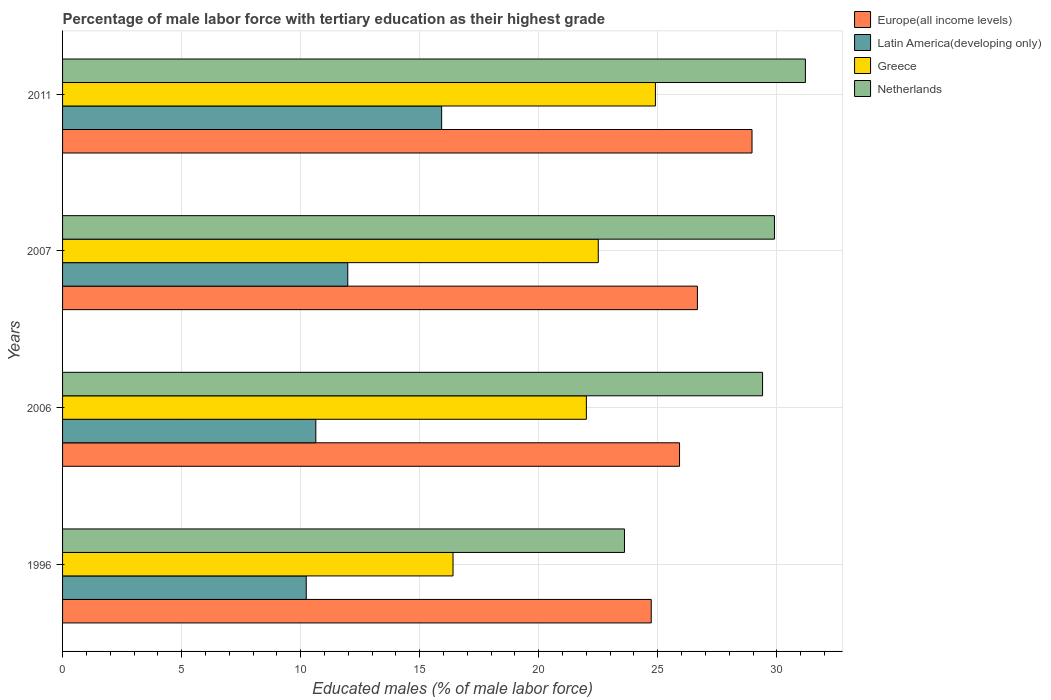How many different coloured bars are there?
Your response must be concise. 4. Are the number of bars per tick equal to the number of legend labels?
Your response must be concise. Yes. In how many cases, is the number of bars for a given year not equal to the number of legend labels?
Offer a very short reply. 0. What is the percentage of male labor force with tertiary education in Greece in 2011?
Provide a succinct answer. 24.9. Across all years, what is the maximum percentage of male labor force with tertiary education in Latin America(developing only)?
Provide a succinct answer. 15.92. Across all years, what is the minimum percentage of male labor force with tertiary education in Latin America(developing only)?
Your answer should be compact. 10.23. In which year was the percentage of male labor force with tertiary education in Greece minimum?
Offer a terse response. 1996. What is the total percentage of male labor force with tertiary education in Netherlands in the graph?
Offer a terse response. 114.1. What is the difference between the percentage of male labor force with tertiary education in Netherlands in 2006 and that in 2011?
Keep it short and to the point. -1.8. What is the difference between the percentage of male labor force with tertiary education in Latin America(developing only) in 2011 and the percentage of male labor force with tertiary education in Europe(all income levels) in 2007?
Your answer should be very brief. -10.74. What is the average percentage of male labor force with tertiary education in Latin America(developing only) per year?
Make the answer very short. 12.19. In the year 2006, what is the difference between the percentage of male labor force with tertiary education in Netherlands and percentage of male labor force with tertiary education in Latin America(developing only)?
Your response must be concise. 18.76. In how many years, is the percentage of male labor force with tertiary education in Europe(all income levels) greater than 3 %?
Provide a succinct answer. 4. What is the ratio of the percentage of male labor force with tertiary education in Netherlands in 2006 to that in 2011?
Keep it short and to the point. 0.94. What is the difference between the highest and the second highest percentage of male labor force with tertiary education in Latin America(developing only)?
Keep it short and to the point. 3.94. What is the difference between the highest and the lowest percentage of male labor force with tertiary education in Netherlands?
Keep it short and to the point. 7.6. What does the 1st bar from the bottom in 2011 represents?
Provide a short and direct response. Europe(all income levels). Are the values on the major ticks of X-axis written in scientific E-notation?
Provide a succinct answer. No. Does the graph contain any zero values?
Make the answer very short. No. Does the graph contain grids?
Provide a succinct answer. Yes. Where does the legend appear in the graph?
Keep it short and to the point. Top right. How many legend labels are there?
Give a very brief answer. 4. What is the title of the graph?
Your answer should be very brief. Percentage of male labor force with tertiary education as their highest grade. Does "Cyprus" appear as one of the legend labels in the graph?
Provide a succinct answer. No. What is the label or title of the X-axis?
Give a very brief answer. Educated males (% of male labor force). What is the Educated males (% of male labor force) of Europe(all income levels) in 1996?
Make the answer very short. 24.72. What is the Educated males (% of male labor force) of Latin America(developing only) in 1996?
Provide a succinct answer. 10.23. What is the Educated males (% of male labor force) in Greece in 1996?
Provide a succinct answer. 16.4. What is the Educated males (% of male labor force) in Netherlands in 1996?
Keep it short and to the point. 23.6. What is the Educated males (% of male labor force) of Europe(all income levels) in 2006?
Your answer should be very brief. 25.91. What is the Educated males (% of male labor force) in Latin America(developing only) in 2006?
Keep it short and to the point. 10.64. What is the Educated males (% of male labor force) in Netherlands in 2006?
Your answer should be very brief. 29.4. What is the Educated males (% of male labor force) of Europe(all income levels) in 2007?
Your answer should be very brief. 26.66. What is the Educated males (% of male labor force) of Latin America(developing only) in 2007?
Your response must be concise. 11.98. What is the Educated males (% of male labor force) in Greece in 2007?
Make the answer very short. 22.5. What is the Educated males (% of male labor force) of Netherlands in 2007?
Your answer should be very brief. 29.9. What is the Educated males (% of male labor force) of Europe(all income levels) in 2011?
Offer a terse response. 28.96. What is the Educated males (% of male labor force) in Latin America(developing only) in 2011?
Keep it short and to the point. 15.92. What is the Educated males (% of male labor force) in Greece in 2011?
Offer a terse response. 24.9. What is the Educated males (% of male labor force) of Netherlands in 2011?
Your response must be concise. 31.2. Across all years, what is the maximum Educated males (% of male labor force) of Europe(all income levels)?
Offer a terse response. 28.96. Across all years, what is the maximum Educated males (% of male labor force) in Latin America(developing only)?
Make the answer very short. 15.92. Across all years, what is the maximum Educated males (% of male labor force) in Greece?
Your response must be concise. 24.9. Across all years, what is the maximum Educated males (% of male labor force) in Netherlands?
Make the answer very short. 31.2. Across all years, what is the minimum Educated males (% of male labor force) in Europe(all income levels)?
Make the answer very short. 24.72. Across all years, what is the minimum Educated males (% of male labor force) in Latin America(developing only)?
Provide a succinct answer. 10.23. Across all years, what is the minimum Educated males (% of male labor force) in Greece?
Make the answer very short. 16.4. Across all years, what is the minimum Educated males (% of male labor force) in Netherlands?
Provide a short and direct response. 23.6. What is the total Educated males (% of male labor force) of Europe(all income levels) in the graph?
Give a very brief answer. 106.26. What is the total Educated males (% of male labor force) of Latin America(developing only) in the graph?
Make the answer very short. 48.77. What is the total Educated males (% of male labor force) of Greece in the graph?
Your answer should be compact. 85.8. What is the total Educated males (% of male labor force) in Netherlands in the graph?
Offer a terse response. 114.1. What is the difference between the Educated males (% of male labor force) in Europe(all income levels) in 1996 and that in 2006?
Provide a succinct answer. -1.19. What is the difference between the Educated males (% of male labor force) in Latin America(developing only) in 1996 and that in 2006?
Ensure brevity in your answer.  -0.4. What is the difference between the Educated males (% of male labor force) of Netherlands in 1996 and that in 2006?
Offer a terse response. -5.8. What is the difference between the Educated males (% of male labor force) in Europe(all income levels) in 1996 and that in 2007?
Provide a short and direct response. -1.94. What is the difference between the Educated males (% of male labor force) in Latin America(developing only) in 1996 and that in 2007?
Keep it short and to the point. -1.74. What is the difference between the Educated males (% of male labor force) in Europe(all income levels) in 1996 and that in 2011?
Give a very brief answer. -4.23. What is the difference between the Educated males (% of male labor force) of Latin America(developing only) in 1996 and that in 2011?
Keep it short and to the point. -5.69. What is the difference between the Educated males (% of male labor force) in Greece in 1996 and that in 2011?
Provide a short and direct response. -8.5. What is the difference between the Educated males (% of male labor force) in Netherlands in 1996 and that in 2011?
Your answer should be very brief. -7.6. What is the difference between the Educated males (% of male labor force) of Europe(all income levels) in 2006 and that in 2007?
Offer a very short reply. -0.75. What is the difference between the Educated males (% of male labor force) in Latin America(developing only) in 2006 and that in 2007?
Your response must be concise. -1.34. What is the difference between the Educated males (% of male labor force) in Netherlands in 2006 and that in 2007?
Keep it short and to the point. -0.5. What is the difference between the Educated males (% of male labor force) in Europe(all income levels) in 2006 and that in 2011?
Your answer should be very brief. -3.04. What is the difference between the Educated males (% of male labor force) in Latin America(developing only) in 2006 and that in 2011?
Give a very brief answer. -5.28. What is the difference between the Educated males (% of male labor force) in Netherlands in 2006 and that in 2011?
Your answer should be compact. -1.8. What is the difference between the Educated males (% of male labor force) of Europe(all income levels) in 2007 and that in 2011?
Provide a succinct answer. -2.29. What is the difference between the Educated males (% of male labor force) of Latin America(developing only) in 2007 and that in 2011?
Ensure brevity in your answer.  -3.94. What is the difference between the Educated males (% of male labor force) in Greece in 2007 and that in 2011?
Your answer should be compact. -2.4. What is the difference between the Educated males (% of male labor force) of Netherlands in 2007 and that in 2011?
Keep it short and to the point. -1.3. What is the difference between the Educated males (% of male labor force) in Europe(all income levels) in 1996 and the Educated males (% of male labor force) in Latin America(developing only) in 2006?
Your answer should be compact. 14.09. What is the difference between the Educated males (% of male labor force) in Europe(all income levels) in 1996 and the Educated males (% of male labor force) in Greece in 2006?
Your answer should be very brief. 2.72. What is the difference between the Educated males (% of male labor force) in Europe(all income levels) in 1996 and the Educated males (% of male labor force) in Netherlands in 2006?
Your answer should be very brief. -4.68. What is the difference between the Educated males (% of male labor force) in Latin America(developing only) in 1996 and the Educated males (% of male labor force) in Greece in 2006?
Offer a very short reply. -11.77. What is the difference between the Educated males (% of male labor force) in Latin America(developing only) in 1996 and the Educated males (% of male labor force) in Netherlands in 2006?
Offer a very short reply. -19.17. What is the difference between the Educated males (% of male labor force) of Greece in 1996 and the Educated males (% of male labor force) of Netherlands in 2006?
Provide a succinct answer. -13. What is the difference between the Educated males (% of male labor force) in Europe(all income levels) in 1996 and the Educated males (% of male labor force) in Latin America(developing only) in 2007?
Keep it short and to the point. 12.74. What is the difference between the Educated males (% of male labor force) in Europe(all income levels) in 1996 and the Educated males (% of male labor force) in Greece in 2007?
Offer a terse response. 2.22. What is the difference between the Educated males (% of male labor force) of Europe(all income levels) in 1996 and the Educated males (% of male labor force) of Netherlands in 2007?
Provide a succinct answer. -5.18. What is the difference between the Educated males (% of male labor force) of Latin America(developing only) in 1996 and the Educated males (% of male labor force) of Greece in 2007?
Make the answer very short. -12.27. What is the difference between the Educated males (% of male labor force) of Latin America(developing only) in 1996 and the Educated males (% of male labor force) of Netherlands in 2007?
Give a very brief answer. -19.67. What is the difference between the Educated males (% of male labor force) in Europe(all income levels) in 1996 and the Educated males (% of male labor force) in Latin America(developing only) in 2011?
Ensure brevity in your answer.  8.8. What is the difference between the Educated males (% of male labor force) of Europe(all income levels) in 1996 and the Educated males (% of male labor force) of Greece in 2011?
Your answer should be compact. -0.18. What is the difference between the Educated males (% of male labor force) of Europe(all income levels) in 1996 and the Educated males (% of male labor force) of Netherlands in 2011?
Keep it short and to the point. -6.48. What is the difference between the Educated males (% of male labor force) in Latin America(developing only) in 1996 and the Educated males (% of male labor force) in Greece in 2011?
Make the answer very short. -14.67. What is the difference between the Educated males (% of male labor force) of Latin America(developing only) in 1996 and the Educated males (% of male labor force) of Netherlands in 2011?
Keep it short and to the point. -20.97. What is the difference between the Educated males (% of male labor force) in Greece in 1996 and the Educated males (% of male labor force) in Netherlands in 2011?
Provide a succinct answer. -14.8. What is the difference between the Educated males (% of male labor force) in Europe(all income levels) in 2006 and the Educated males (% of male labor force) in Latin America(developing only) in 2007?
Give a very brief answer. 13.93. What is the difference between the Educated males (% of male labor force) of Europe(all income levels) in 2006 and the Educated males (% of male labor force) of Greece in 2007?
Your response must be concise. 3.41. What is the difference between the Educated males (% of male labor force) of Europe(all income levels) in 2006 and the Educated males (% of male labor force) of Netherlands in 2007?
Your answer should be compact. -3.99. What is the difference between the Educated males (% of male labor force) in Latin America(developing only) in 2006 and the Educated males (% of male labor force) in Greece in 2007?
Your response must be concise. -11.86. What is the difference between the Educated males (% of male labor force) of Latin America(developing only) in 2006 and the Educated males (% of male labor force) of Netherlands in 2007?
Your answer should be very brief. -19.26. What is the difference between the Educated males (% of male labor force) in Europe(all income levels) in 2006 and the Educated males (% of male labor force) in Latin America(developing only) in 2011?
Offer a very short reply. 9.99. What is the difference between the Educated males (% of male labor force) in Europe(all income levels) in 2006 and the Educated males (% of male labor force) in Greece in 2011?
Make the answer very short. 1.01. What is the difference between the Educated males (% of male labor force) of Europe(all income levels) in 2006 and the Educated males (% of male labor force) of Netherlands in 2011?
Provide a succinct answer. -5.29. What is the difference between the Educated males (% of male labor force) of Latin America(developing only) in 2006 and the Educated males (% of male labor force) of Greece in 2011?
Provide a short and direct response. -14.26. What is the difference between the Educated males (% of male labor force) in Latin America(developing only) in 2006 and the Educated males (% of male labor force) in Netherlands in 2011?
Offer a terse response. -20.56. What is the difference between the Educated males (% of male labor force) of Greece in 2006 and the Educated males (% of male labor force) of Netherlands in 2011?
Provide a succinct answer. -9.2. What is the difference between the Educated males (% of male labor force) of Europe(all income levels) in 2007 and the Educated males (% of male labor force) of Latin America(developing only) in 2011?
Give a very brief answer. 10.74. What is the difference between the Educated males (% of male labor force) of Europe(all income levels) in 2007 and the Educated males (% of male labor force) of Greece in 2011?
Offer a very short reply. 1.76. What is the difference between the Educated males (% of male labor force) of Europe(all income levels) in 2007 and the Educated males (% of male labor force) of Netherlands in 2011?
Ensure brevity in your answer.  -4.54. What is the difference between the Educated males (% of male labor force) of Latin America(developing only) in 2007 and the Educated males (% of male labor force) of Greece in 2011?
Offer a very short reply. -12.92. What is the difference between the Educated males (% of male labor force) in Latin America(developing only) in 2007 and the Educated males (% of male labor force) in Netherlands in 2011?
Provide a short and direct response. -19.22. What is the average Educated males (% of male labor force) of Europe(all income levels) per year?
Provide a succinct answer. 26.56. What is the average Educated males (% of male labor force) in Latin America(developing only) per year?
Make the answer very short. 12.19. What is the average Educated males (% of male labor force) of Greece per year?
Keep it short and to the point. 21.45. What is the average Educated males (% of male labor force) in Netherlands per year?
Keep it short and to the point. 28.52. In the year 1996, what is the difference between the Educated males (% of male labor force) in Europe(all income levels) and Educated males (% of male labor force) in Latin America(developing only)?
Offer a terse response. 14.49. In the year 1996, what is the difference between the Educated males (% of male labor force) of Europe(all income levels) and Educated males (% of male labor force) of Greece?
Provide a succinct answer. 8.32. In the year 1996, what is the difference between the Educated males (% of male labor force) of Europe(all income levels) and Educated males (% of male labor force) of Netherlands?
Provide a succinct answer. 1.12. In the year 1996, what is the difference between the Educated males (% of male labor force) in Latin America(developing only) and Educated males (% of male labor force) in Greece?
Provide a succinct answer. -6.17. In the year 1996, what is the difference between the Educated males (% of male labor force) in Latin America(developing only) and Educated males (% of male labor force) in Netherlands?
Offer a very short reply. -13.37. In the year 1996, what is the difference between the Educated males (% of male labor force) of Greece and Educated males (% of male labor force) of Netherlands?
Make the answer very short. -7.2. In the year 2006, what is the difference between the Educated males (% of male labor force) in Europe(all income levels) and Educated males (% of male labor force) in Latin America(developing only)?
Keep it short and to the point. 15.28. In the year 2006, what is the difference between the Educated males (% of male labor force) in Europe(all income levels) and Educated males (% of male labor force) in Greece?
Give a very brief answer. 3.91. In the year 2006, what is the difference between the Educated males (% of male labor force) in Europe(all income levels) and Educated males (% of male labor force) in Netherlands?
Offer a terse response. -3.49. In the year 2006, what is the difference between the Educated males (% of male labor force) of Latin America(developing only) and Educated males (% of male labor force) of Greece?
Offer a very short reply. -11.36. In the year 2006, what is the difference between the Educated males (% of male labor force) of Latin America(developing only) and Educated males (% of male labor force) of Netherlands?
Ensure brevity in your answer.  -18.76. In the year 2007, what is the difference between the Educated males (% of male labor force) in Europe(all income levels) and Educated males (% of male labor force) in Latin America(developing only)?
Make the answer very short. 14.68. In the year 2007, what is the difference between the Educated males (% of male labor force) of Europe(all income levels) and Educated males (% of male labor force) of Greece?
Your answer should be very brief. 4.16. In the year 2007, what is the difference between the Educated males (% of male labor force) of Europe(all income levels) and Educated males (% of male labor force) of Netherlands?
Offer a very short reply. -3.24. In the year 2007, what is the difference between the Educated males (% of male labor force) in Latin America(developing only) and Educated males (% of male labor force) in Greece?
Offer a very short reply. -10.52. In the year 2007, what is the difference between the Educated males (% of male labor force) in Latin America(developing only) and Educated males (% of male labor force) in Netherlands?
Your answer should be compact. -17.92. In the year 2007, what is the difference between the Educated males (% of male labor force) of Greece and Educated males (% of male labor force) of Netherlands?
Your response must be concise. -7.4. In the year 2011, what is the difference between the Educated males (% of male labor force) of Europe(all income levels) and Educated males (% of male labor force) of Latin America(developing only)?
Give a very brief answer. 13.04. In the year 2011, what is the difference between the Educated males (% of male labor force) of Europe(all income levels) and Educated males (% of male labor force) of Greece?
Your answer should be very brief. 4.06. In the year 2011, what is the difference between the Educated males (% of male labor force) of Europe(all income levels) and Educated males (% of male labor force) of Netherlands?
Keep it short and to the point. -2.24. In the year 2011, what is the difference between the Educated males (% of male labor force) in Latin America(developing only) and Educated males (% of male labor force) in Greece?
Your answer should be compact. -8.98. In the year 2011, what is the difference between the Educated males (% of male labor force) in Latin America(developing only) and Educated males (% of male labor force) in Netherlands?
Your answer should be compact. -15.28. In the year 2011, what is the difference between the Educated males (% of male labor force) of Greece and Educated males (% of male labor force) of Netherlands?
Offer a very short reply. -6.3. What is the ratio of the Educated males (% of male labor force) of Europe(all income levels) in 1996 to that in 2006?
Your answer should be compact. 0.95. What is the ratio of the Educated males (% of male labor force) in Latin America(developing only) in 1996 to that in 2006?
Your answer should be compact. 0.96. What is the ratio of the Educated males (% of male labor force) in Greece in 1996 to that in 2006?
Ensure brevity in your answer.  0.75. What is the ratio of the Educated males (% of male labor force) in Netherlands in 1996 to that in 2006?
Provide a succinct answer. 0.8. What is the ratio of the Educated males (% of male labor force) in Europe(all income levels) in 1996 to that in 2007?
Your answer should be very brief. 0.93. What is the ratio of the Educated males (% of male labor force) of Latin America(developing only) in 1996 to that in 2007?
Your answer should be compact. 0.85. What is the ratio of the Educated males (% of male labor force) of Greece in 1996 to that in 2007?
Provide a short and direct response. 0.73. What is the ratio of the Educated males (% of male labor force) in Netherlands in 1996 to that in 2007?
Your response must be concise. 0.79. What is the ratio of the Educated males (% of male labor force) in Europe(all income levels) in 1996 to that in 2011?
Your response must be concise. 0.85. What is the ratio of the Educated males (% of male labor force) in Latin America(developing only) in 1996 to that in 2011?
Your response must be concise. 0.64. What is the ratio of the Educated males (% of male labor force) in Greece in 1996 to that in 2011?
Ensure brevity in your answer.  0.66. What is the ratio of the Educated males (% of male labor force) of Netherlands in 1996 to that in 2011?
Your answer should be very brief. 0.76. What is the ratio of the Educated males (% of male labor force) of Europe(all income levels) in 2006 to that in 2007?
Offer a very short reply. 0.97. What is the ratio of the Educated males (% of male labor force) of Latin America(developing only) in 2006 to that in 2007?
Provide a short and direct response. 0.89. What is the ratio of the Educated males (% of male labor force) of Greece in 2006 to that in 2007?
Your answer should be very brief. 0.98. What is the ratio of the Educated males (% of male labor force) in Netherlands in 2006 to that in 2007?
Provide a succinct answer. 0.98. What is the ratio of the Educated males (% of male labor force) of Europe(all income levels) in 2006 to that in 2011?
Keep it short and to the point. 0.89. What is the ratio of the Educated males (% of male labor force) of Latin America(developing only) in 2006 to that in 2011?
Your answer should be compact. 0.67. What is the ratio of the Educated males (% of male labor force) of Greece in 2006 to that in 2011?
Give a very brief answer. 0.88. What is the ratio of the Educated males (% of male labor force) of Netherlands in 2006 to that in 2011?
Keep it short and to the point. 0.94. What is the ratio of the Educated males (% of male labor force) in Europe(all income levels) in 2007 to that in 2011?
Make the answer very short. 0.92. What is the ratio of the Educated males (% of male labor force) in Latin America(developing only) in 2007 to that in 2011?
Your response must be concise. 0.75. What is the ratio of the Educated males (% of male labor force) in Greece in 2007 to that in 2011?
Make the answer very short. 0.9. What is the ratio of the Educated males (% of male labor force) of Netherlands in 2007 to that in 2011?
Your answer should be very brief. 0.96. What is the difference between the highest and the second highest Educated males (% of male labor force) in Europe(all income levels)?
Give a very brief answer. 2.29. What is the difference between the highest and the second highest Educated males (% of male labor force) in Latin America(developing only)?
Offer a very short reply. 3.94. What is the difference between the highest and the second highest Educated males (% of male labor force) in Netherlands?
Your answer should be very brief. 1.3. What is the difference between the highest and the lowest Educated males (% of male labor force) in Europe(all income levels)?
Offer a terse response. 4.23. What is the difference between the highest and the lowest Educated males (% of male labor force) in Latin America(developing only)?
Make the answer very short. 5.69. What is the difference between the highest and the lowest Educated males (% of male labor force) of Greece?
Provide a short and direct response. 8.5. 